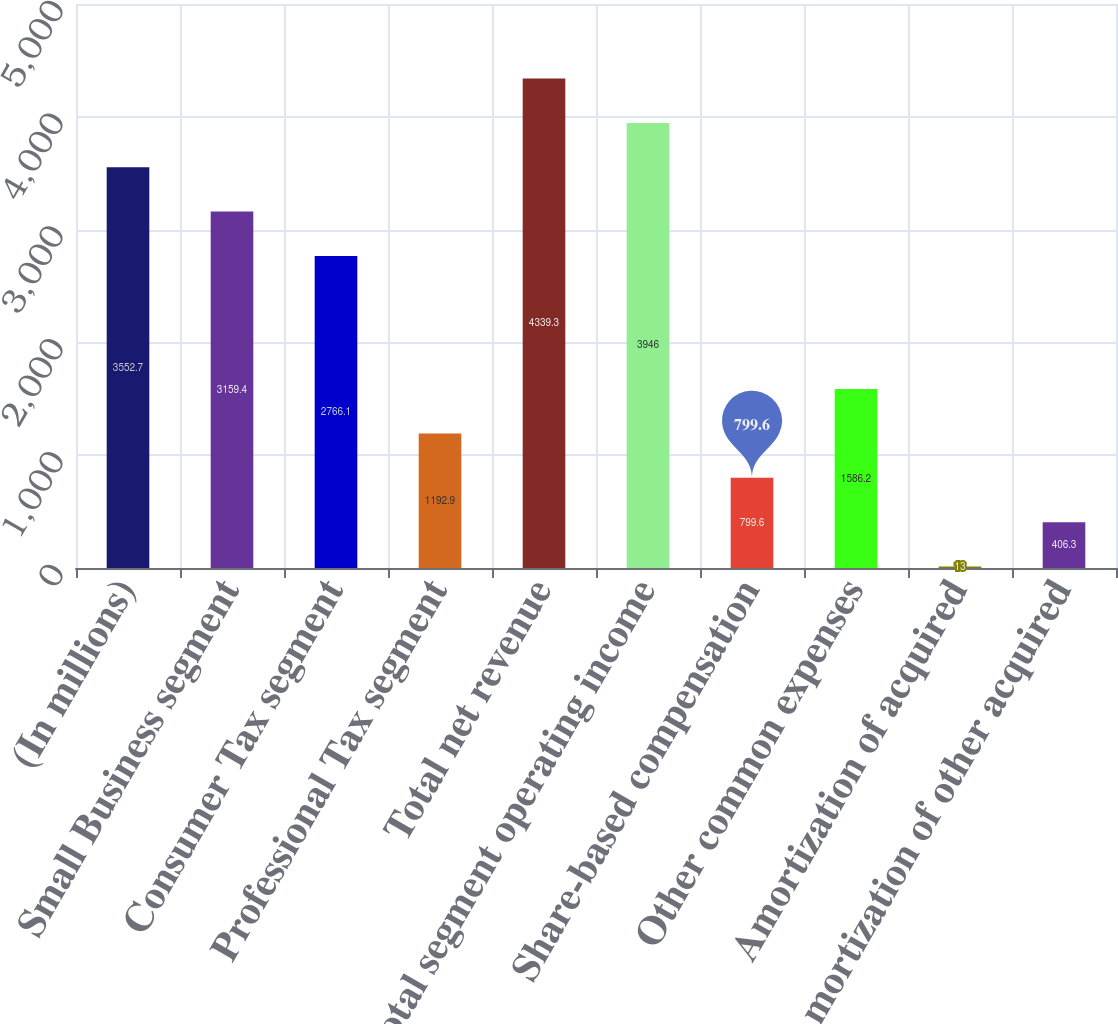<chart> <loc_0><loc_0><loc_500><loc_500><bar_chart><fcel>(In millions)<fcel>Small Business segment<fcel>Consumer Tax segment<fcel>Professional Tax segment<fcel>Total net revenue<fcel>Total segment operating income<fcel>Share-based compensation<fcel>Other common expenses<fcel>Amortization of acquired<fcel>Amortization of other acquired<nl><fcel>3552.7<fcel>3159.4<fcel>2766.1<fcel>1192.9<fcel>4339.3<fcel>3946<fcel>799.6<fcel>1586.2<fcel>13<fcel>406.3<nl></chart> 